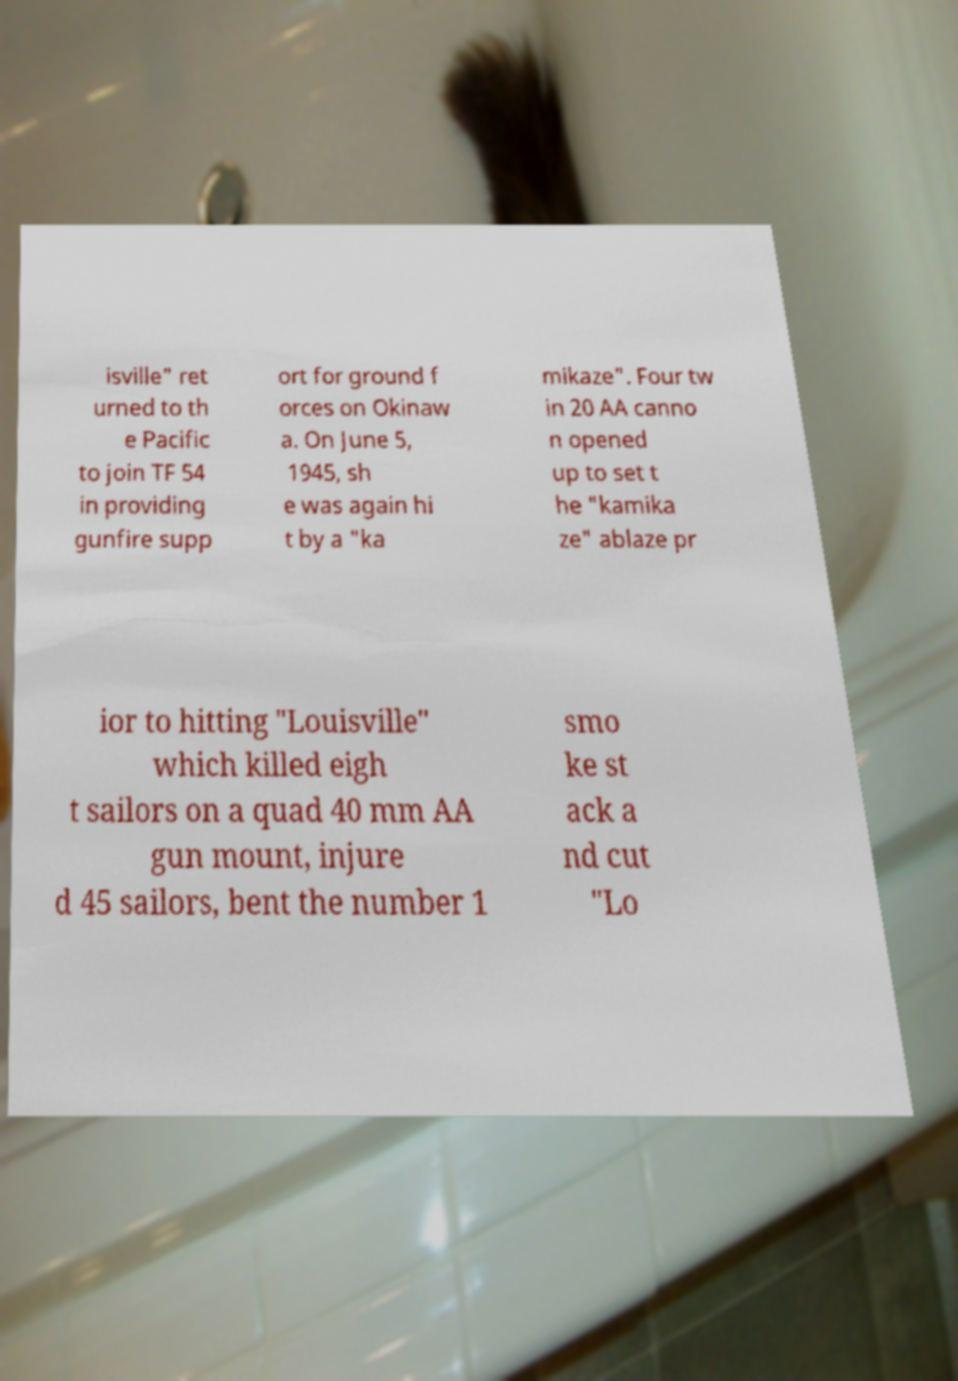Can you read and provide the text displayed in the image?This photo seems to have some interesting text. Can you extract and type it out for me? isville" ret urned to th e Pacific to join TF 54 in providing gunfire supp ort for ground f orces on Okinaw a. On June 5, 1945, sh e was again hi t by a "ka mikaze". Four tw in 20 AA canno n opened up to set t he "kamika ze" ablaze pr ior to hitting "Louisville" which killed eigh t sailors on a quad 40 mm AA gun mount, injure d 45 sailors, bent the number 1 smo ke st ack a nd cut "Lo 